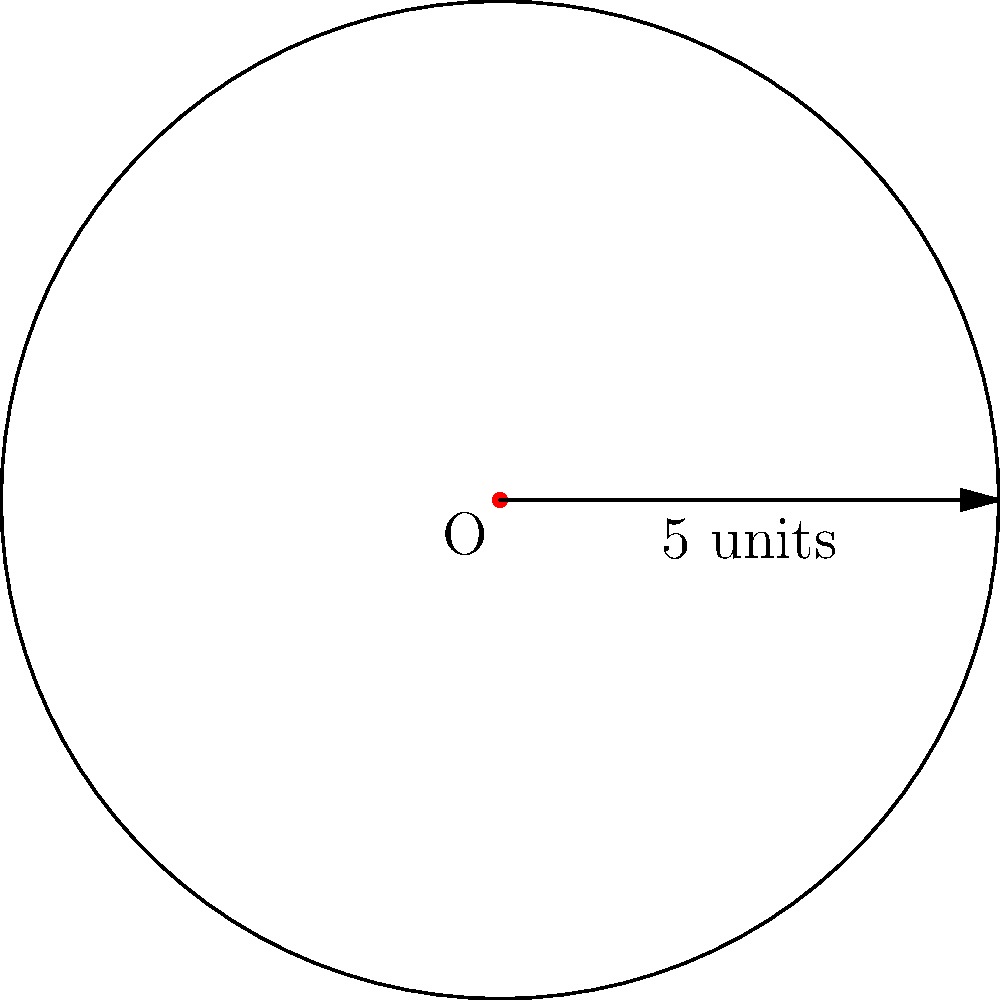As a writer drawing inspiration from rancher experiences, you're researching circular pastures. A rancher tells you about a perfectly circular pasture with a radius of 5 units. Using polar coordinates, calculate the area of this pasture. Round your answer to two decimal places. To calculate the area of a circular region using polar coordinates, we can use the formula:

$$ A = \frac{1}{2} \int_{0}^{2\pi} r^2(\theta) d\theta $$

Where $r(\theta)$ is the function that describes the boundary of the region.

For a circle with radius 5 units, $r(\theta) = 5$ for all $\theta$.

Let's solve this step-by-step:

1) Substitute $r(\theta) = 5$ into the formula:

   $$ A = \frac{1}{2} \int_{0}^{2\pi} 5^2 d\theta $$

2) Simplify:

   $$ A = \frac{1}{2} \int_{0}^{2\pi} 25 d\theta $$

3) Integrate:

   $$ A = \frac{1}{2} [25\theta]_{0}^{2\pi} $$

4) Evaluate the integral:

   $$ A = \frac{1}{2} (25 \cdot 2\pi - 25 \cdot 0) = \frac{1}{2} \cdot 50\pi = 25\pi $$

5) Round to two decimal places:

   $$ A \approx 78.54 \text{ square units} $$

This matches the familiar formula for the area of a circle, $A = \pi r^2 = \pi \cdot 5^2 = 25\pi$.
Answer: $78.54$ square units 